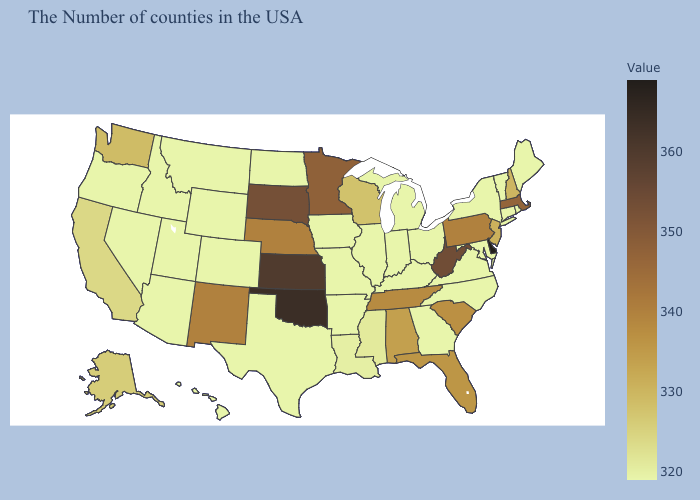Does Washington have a higher value than Kentucky?
Concise answer only. Yes. Does North Carolina have a higher value than New Mexico?
Give a very brief answer. No. Is the legend a continuous bar?
Short answer required. Yes. Among the states that border Texas , does New Mexico have the highest value?
Give a very brief answer. No. 